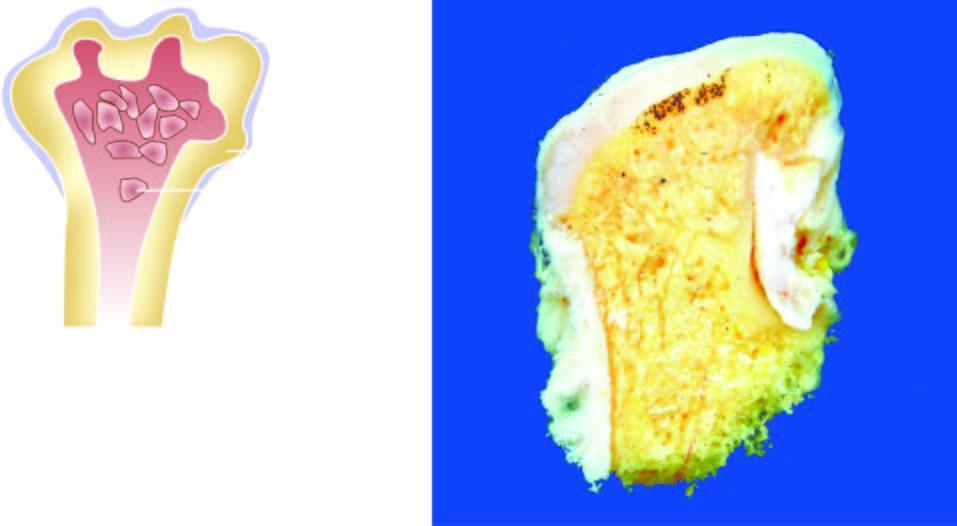what shows mushroom-shaped elevated nodular areas?
Answer the question using a single word or phrase. Amputated head of the long bone 